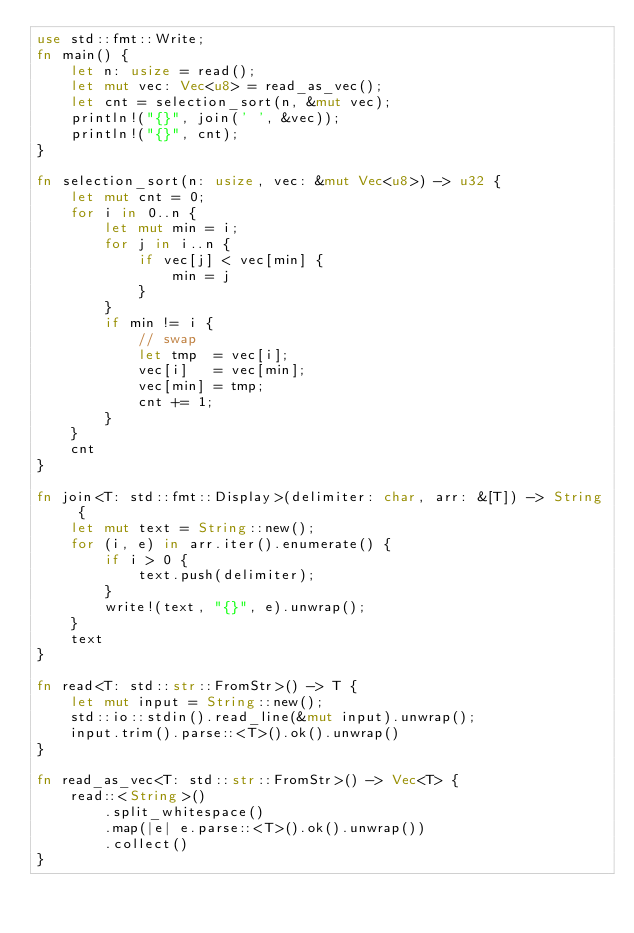<code> <loc_0><loc_0><loc_500><loc_500><_Rust_>use std::fmt::Write;
fn main() {
    let n: usize = read();
    let mut vec: Vec<u8> = read_as_vec();
    let cnt = selection_sort(n, &mut vec);
    println!("{}", join(' ', &vec));
    println!("{}", cnt);
}

fn selection_sort(n: usize, vec: &mut Vec<u8>) -> u32 {
    let mut cnt = 0;
    for i in 0..n {
        let mut min = i;
        for j in i..n {
            if vec[j] < vec[min] {
                min = j
            }
        }
        if min != i {
            // swap
            let tmp  = vec[i];
            vec[i]   = vec[min];
            vec[min] = tmp;
            cnt += 1;
        }
    }
    cnt
}

fn join<T: std::fmt::Display>(delimiter: char, arr: &[T]) -> String {
    let mut text = String::new();
    for (i, e) in arr.iter().enumerate() {
        if i > 0 {
            text.push(delimiter);
        }
        write!(text, "{}", e).unwrap();
    }
    text
}

fn read<T: std::str::FromStr>() -> T {
    let mut input = String::new();
    std::io::stdin().read_line(&mut input).unwrap();
    input.trim().parse::<T>().ok().unwrap()
}

fn read_as_vec<T: std::str::FromStr>() -> Vec<T> {
    read::<String>()
        .split_whitespace()
        .map(|e| e.parse::<T>().ok().unwrap())
        .collect()
}
</code> 